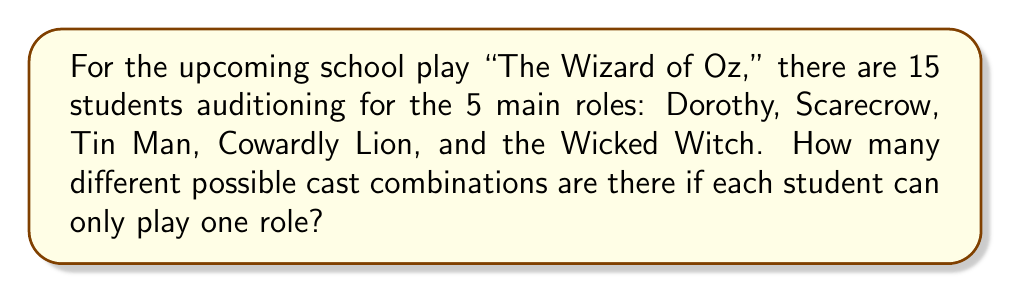Solve this math problem. Let's approach this step-by-step:

1) This is a permutation problem, as the order matters (each role is distinct).

2) We are selecting 5 students out of 15 for specific roles, where each student can only be chosen once.

3) The formula for this type of permutation is:

   $$P(n,r) = \frac{n!}{(n-r)!}$$

   Where $n$ is the total number of items to choose from, and $r$ is the number of items being chosen.

4) In this case, $n = 15$ (total students) and $r = 5$ (roles to be filled).

5) Plugging these numbers into our formula:

   $$P(15,5) = \frac{15!}{(15-5)!} = \frac{15!}{10!}$$

6) Expand this:
   
   $$\frac{15 \times 14 \times 13 \times 12 \times 11 \times 10!}{10!}$$

7) The 10! cancels out in the numerator and denominator:

   $$15 \times 14 \times 13 \times 12 \times 11 = 360,360$$

Therefore, there are 360,360 different possible cast combinations for the main roles in "The Wizard of Oz."
Answer: 360,360 